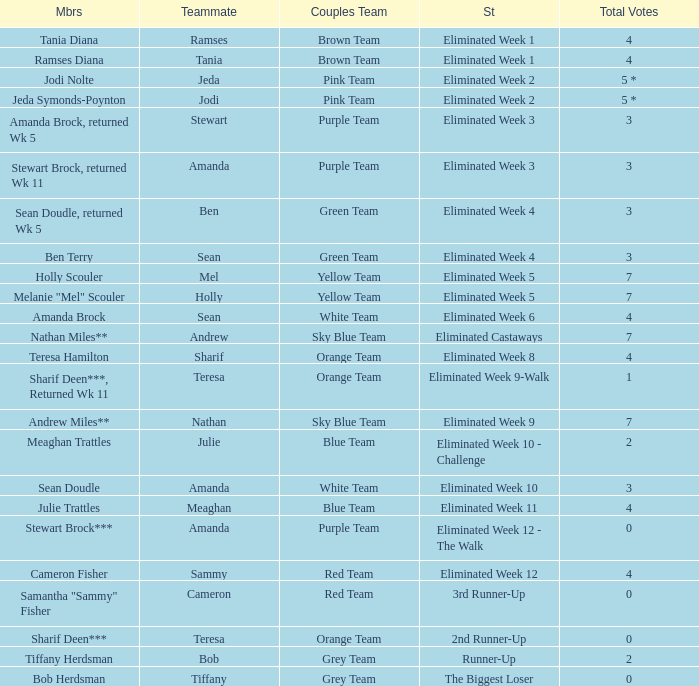Who had 0 total votes in the purple team? Eliminated Week 12 - The Walk. 